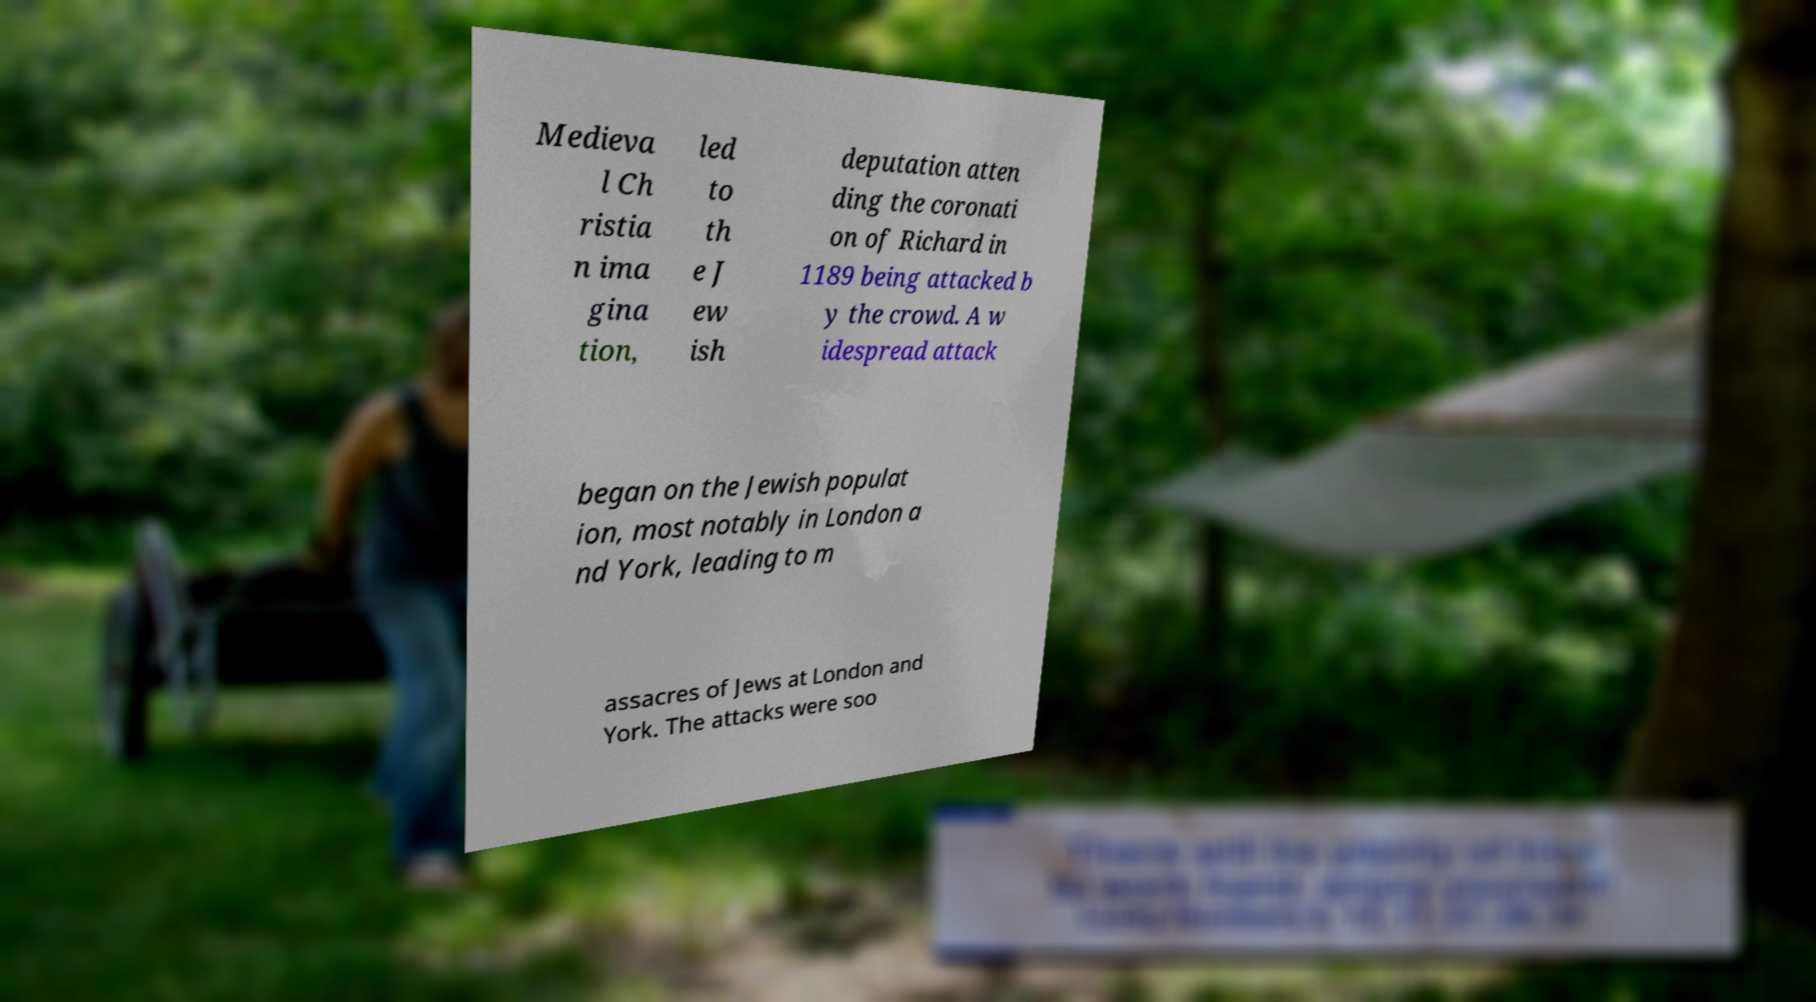Could you extract and type out the text from this image? Medieva l Ch ristia n ima gina tion, led to th e J ew ish deputation atten ding the coronati on of Richard in 1189 being attacked b y the crowd. A w idespread attack began on the Jewish populat ion, most notably in London a nd York, leading to m assacres of Jews at London and York. The attacks were soo 